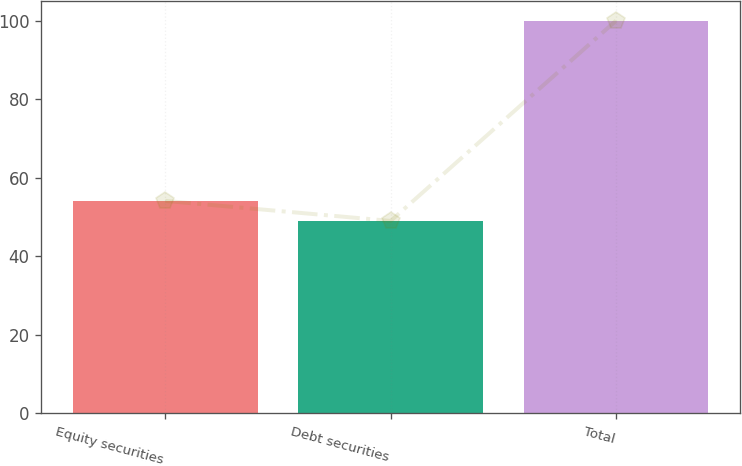Convert chart to OTSL. <chart><loc_0><loc_0><loc_500><loc_500><bar_chart><fcel>Equity securities<fcel>Debt securities<fcel>Total<nl><fcel>54.1<fcel>49<fcel>100<nl></chart> 